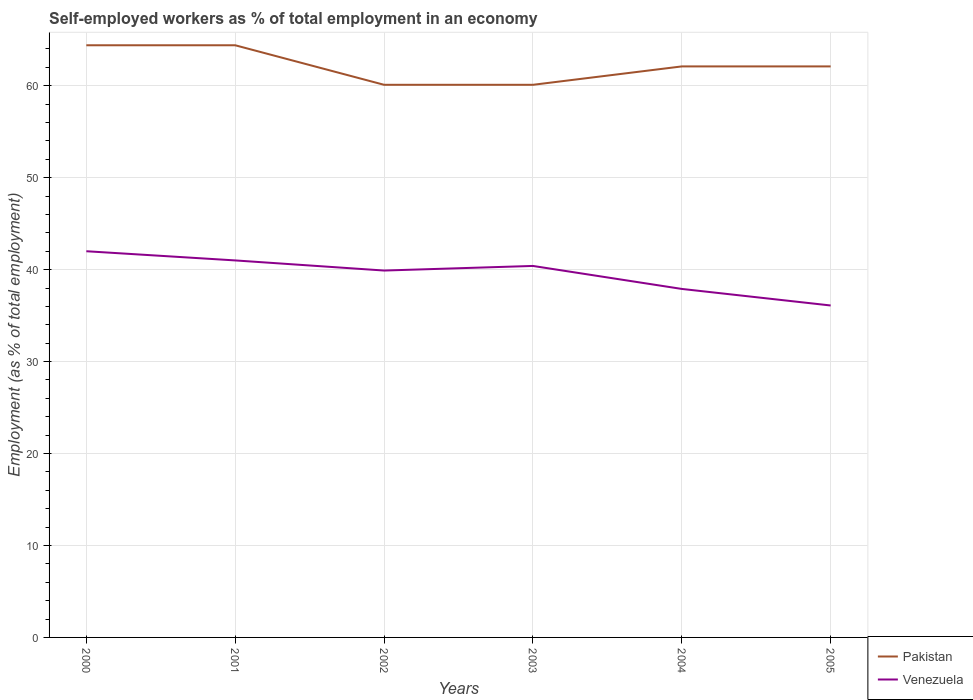Across all years, what is the maximum percentage of self-employed workers in Pakistan?
Offer a very short reply. 60.1. In which year was the percentage of self-employed workers in Venezuela maximum?
Ensure brevity in your answer.  2005. What is the total percentage of self-employed workers in Venezuela in the graph?
Offer a terse response. 0.6. What is the difference between the highest and the second highest percentage of self-employed workers in Pakistan?
Make the answer very short. 4.3. What is the difference between the highest and the lowest percentage of self-employed workers in Venezuela?
Give a very brief answer. 4. How many years are there in the graph?
Ensure brevity in your answer.  6. What is the difference between two consecutive major ticks on the Y-axis?
Provide a succinct answer. 10. Are the values on the major ticks of Y-axis written in scientific E-notation?
Your answer should be very brief. No. Does the graph contain any zero values?
Provide a succinct answer. No. How many legend labels are there?
Provide a succinct answer. 2. What is the title of the graph?
Make the answer very short. Self-employed workers as % of total employment in an economy. Does "Canada" appear as one of the legend labels in the graph?
Your response must be concise. No. What is the label or title of the Y-axis?
Provide a succinct answer. Employment (as % of total employment). What is the Employment (as % of total employment) of Pakistan in 2000?
Offer a very short reply. 64.4. What is the Employment (as % of total employment) in Pakistan in 2001?
Make the answer very short. 64.4. What is the Employment (as % of total employment) of Venezuela in 2001?
Offer a very short reply. 41. What is the Employment (as % of total employment) of Pakistan in 2002?
Your response must be concise. 60.1. What is the Employment (as % of total employment) of Venezuela in 2002?
Your answer should be compact. 39.9. What is the Employment (as % of total employment) in Pakistan in 2003?
Keep it short and to the point. 60.1. What is the Employment (as % of total employment) in Venezuela in 2003?
Give a very brief answer. 40.4. What is the Employment (as % of total employment) in Pakistan in 2004?
Ensure brevity in your answer.  62.1. What is the Employment (as % of total employment) in Venezuela in 2004?
Offer a very short reply. 37.9. What is the Employment (as % of total employment) in Pakistan in 2005?
Give a very brief answer. 62.1. What is the Employment (as % of total employment) of Venezuela in 2005?
Provide a short and direct response. 36.1. Across all years, what is the maximum Employment (as % of total employment) in Pakistan?
Your answer should be very brief. 64.4. Across all years, what is the minimum Employment (as % of total employment) in Pakistan?
Your answer should be very brief. 60.1. Across all years, what is the minimum Employment (as % of total employment) in Venezuela?
Your response must be concise. 36.1. What is the total Employment (as % of total employment) in Pakistan in the graph?
Keep it short and to the point. 373.2. What is the total Employment (as % of total employment) of Venezuela in the graph?
Provide a short and direct response. 237.3. What is the difference between the Employment (as % of total employment) of Pakistan in 2000 and that in 2001?
Your answer should be very brief. 0. What is the difference between the Employment (as % of total employment) of Venezuela in 2000 and that in 2001?
Your answer should be very brief. 1. What is the difference between the Employment (as % of total employment) in Pakistan in 2000 and that in 2003?
Provide a short and direct response. 4.3. What is the difference between the Employment (as % of total employment) in Venezuela in 2000 and that in 2003?
Your answer should be compact. 1.6. What is the difference between the Employment (as % of total employment) in Pakistan in 2000 and that in 2004?
Give a very brief answer. 2.3. What is the difference between the Employment (as % of total employment) of Venezuela in 2000 and that in 2004?
Your response must be concise. 4.1. What is the difference between the Employment (as % of total employment) of Venezuela in 2000 and that in 2005?
Provide a short and direct response. 5.9. What is the difference between the Employment (as % of total employment) of Venezuela in 2001 and that in 2005?
Provide a succinct answer. 4.9. What is the difference between the Employment (as % of total employment) of Pakistan in 2003 and that in 2004?
Offer a very short reply. -2. What is the difference between the Employment (as % of total employment) of Venezuela in 2003 and that in 2004?
Your answer should be compact. 2.5. What is the difference between the Employment (as % of total employment) of Venezuela in 2003 and that in 2005?
Give a very brief answer. 4.3. What is the difference between the Employment (as % of total employment) of Venezuela in 2004 and that in 2005?
Ensure brevity in your answer.  1.8. What is the difference between the Employment (as % of total employment) of Pakistan in 2000 and the Employment (as % of total employment) of Venezuela in 2001?
Offer a terse response. 23.4. What is the difference between the Employment (as % of total employment) in Pakistan in 2000 and the Employment (as % of total employment) in Venezuela in 2004?
Your response must be concise. 26.5. What is the difference between the Employment (as % of total employment) of Pakistan in 2000 and the Employment (as % of total employment) of Venezuela in 2005?
Offer a very short reply. 28.3. What is the difference between the Employment (as % of total employment) in Pakistan in 2001 and the Employment (as % of total employment) in Venezuela in 2002?
Your answer should be very brief. 24.5. What is the difference between the Employment (as % of total employment) of Pakistan in 2001 and the Employment (as % of total employment) of Venezuela in 2005?
Provide a short and direct response. 28.3. What is the difference between the Employment (as % of total employment) in Pakistan in 2003 and the Employment (as % of total employment) in Venezuela in 2004?
Provide a succinct answer. 22.2. What is the difference between the Employment (as % of total employment) of Pakistan in 2003 and the Employment (as % of total employment) of Venezuela in 2005?
Your answer should be compact. 24. What is the average Employment (as % of total employment) in Pakistan per year?
Offer a very short reply. 62.2. What is the average Employment (as % of total employment) in Venezuela per year?
Give a very brief answer. 39.55. In the year 2000, what is the difference between the Employment (as % of total employment) in Pakistan and Employment (as % of total employment) in Venezuela?
Ensure brevity in your answer.  22.4. In the year 2001, what is the difference between the Employment (as % of total employment) of Pakistan and Employment (as % of total employment) of Venezuela?
Give a very brief answer. 23.4. In the year 2002, what is the difference between the Employment (as % of total employment) in Pakistan and Employment (as % of total employment) in Venezuela?
Provide a succinct answer. 20.2. In the year 2004, what is the difference between the Employment (as % of total employment) in Pakistan and Employment (as % of total employment) in Venezuela?
Make the answer very short. 24.2. In the year 2005, what is the difference between the Employment (as % of total employment) in Pakistan and Employment (as % of total employment) in Venezuela?
Keep it short and to the point. 26. What is the ratio of the Employment (as % of total employment) in Venezuela in 2000 to that in 2001?
Your answer should be very brief. 1.02. What is the ratio of the Employment (as % of total employment) in Pakistan in 2000 to that in 2002?
Your response must be concise. 1.07. What is the ratio of the Employment (as % of total employment) in Venezuela in 2000 to that in 2002?
Ensure brevity in your answer.  1.05. What is the ratio of the Employment (as % of total employment) of Pakistan in 2000 to that in 2003?
Your answer should be compact. 1.07. What is the ratio of the Employment (as % of total employment) of Venezuela in 2000 to that in 2003?
Ensure brevity in your answer.  1.04. What is the ratio of the Employment (as % of total employment) in Venezuela in 2000 to that in 2004?
Keep it short and to the point. 1.11. What is the ratio of the Employment (as % of total employment) in Venezuela in 2000 to that in 2005?
Provide a succinct answer. 1.16. What is the ratio of the Employment (as % of total employment) of Pakistan in 2001 to that in 2002?
Give a very brief answer. 1.07. What is the ratio of the Employment (as % of total employment) in Venezuela in 2001 to that in 2002?
Your response must be concise. 1.03. What is the ratio of the Employment (as % of total employment) in Pakistan in 2001 to that in 2003?
Give a very brief answer. 1.07. What is the ratio of the Employment (as % of total employment) of Venezuela in 2001 to that in 2003?
Your response must be concise. 1.01. What is the ratio of the Employment (as % of total employment) in Venezuela in 2001 to that in 2004?
Give a very brief answer. 1.08. What is the ratio of the Employment (as % of total employment) of Pakistan in 2001 to that in 2005?
Your response must be concise. 1.04. What is the ratio of the Employment (as % of total employment) in Venezuela in 2001 to that in 2005?
Keep it short and to the point. 1.14. What is the ratio of the Employment (as % of total employment) in Pakistan in 2002 to that in 2003?
Provide a short and direct response. 1. What is the ratio of the Employment (as % of total employment) of Venezuela in 2002 to that in 2003?
Offer a terse response. 0.99. What is the ratio of the Employment (as % of total employment) of Pakistan in 2002 to that in 2004?
Give a very brief answer. 0.97. What is the ratio of the Employment (as % of total employment) of Venezuela in 2002 to that in 2004?
Give a very brief answer. 1.05. What is the ratio of the Employment (as % of total employment) of Pakistan in 2002 to that in 2005?
Your answer should be compact. 0.97. What is the ratio of the Employment (as % of total employment) in Venezuela in 2002 to that in 2005?
Ensure brevity in your answer.  1.11. What is the ratio of the Employment (as % of total employment) of Pakistan in 2003 to that in 2004?
Your answer should be very brief. 0.97. What is the ratio of the Employment (as % of total employment) of Venezuela in 2003 to that in 2004?
Keep it short and to the point. 1.07. What is the ratio of the Employment (as % of total employment) of Pakistan in 2003 to that in 2005?
Provide a succinct answer. 0.97. What is the ratio of the Employment (as % of total employment) in Venezuela in 2003 to that in 2005?
Your answer should be very brief. 1.12. What is the ratio of the Employment (as % of total employment) of Venezuela in 2004 to that in 2005?
Your answer should be very brief. 1.05. What is the difference between the highest and the second highest Employment (as % of total employment) of Pakistan?
Offer a very short reply. 0. What is the difference between the highest and the second highest Employment (as % of total employment) in Venezuela?
Your answer should be very brief. 1. 